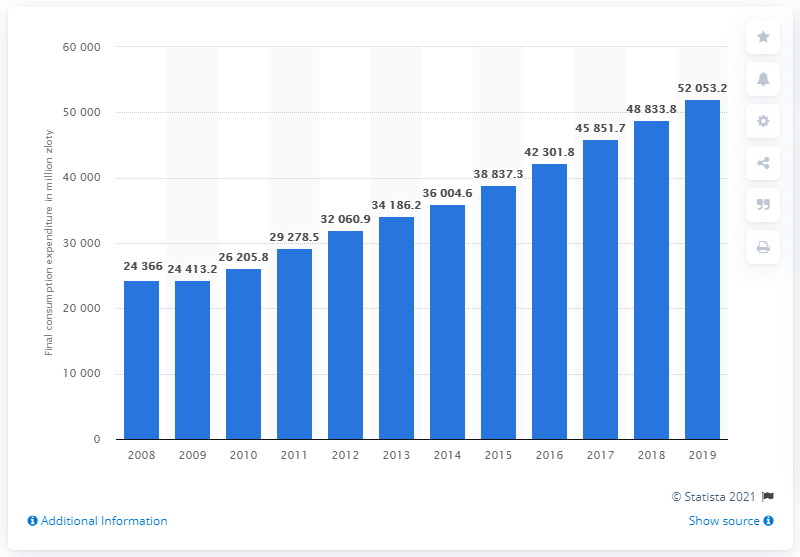Mention a couple of crucial points in this snapshot. According to data from 2019, the total expenditure on clothing in Poland was approximately 52,053.2 units. 